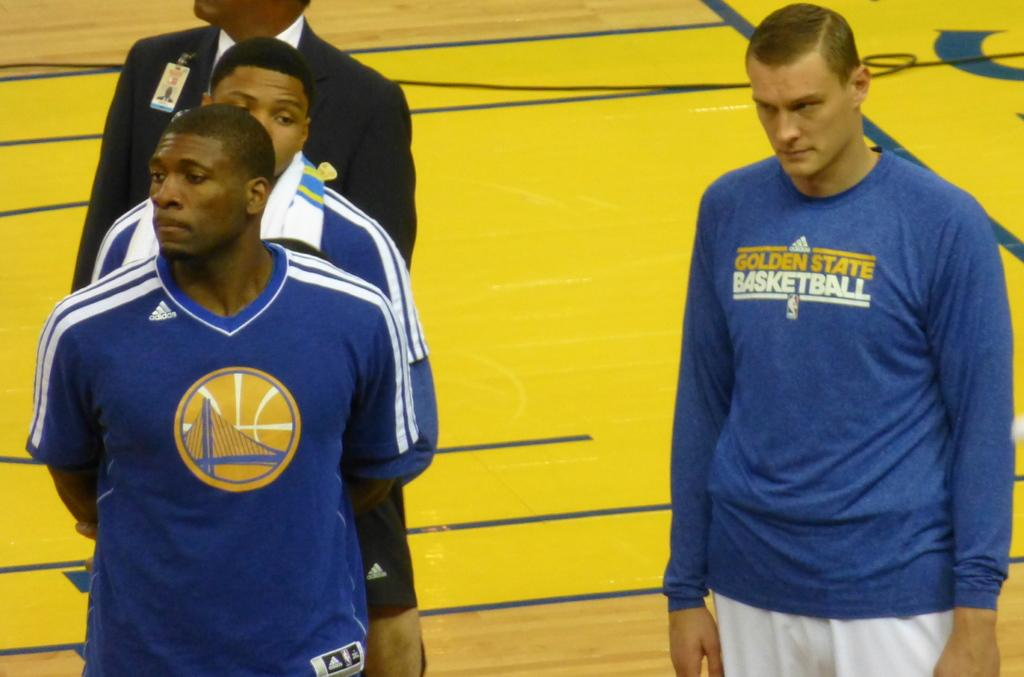<image>
Give a short and clear explanation of the subsequent image. A guy wearing a blue Golden State Basketball shirt. 